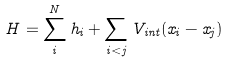Convert formula to latex. <formula><loc_0><loc_0><loc_500><loc_500>H = \sum _ { i } ^ { N } h _ { i } + \sum _ { i < j } V _ { i n t } ( x _ { i } - x _ { j } )</formula> 